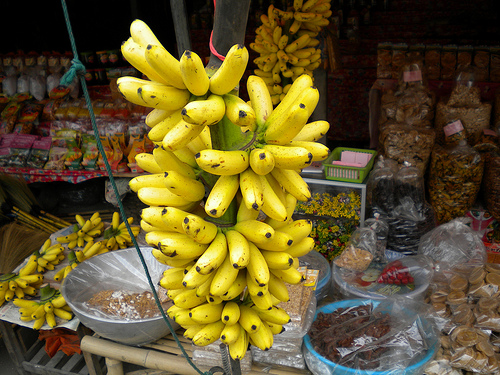Please provide a short description for this region: [0.41, 0.47, 0.47, 0.56]. This section of the image once again features the striking ripe yellow bananas, practically begging to be picked up and enjoyed right from the market stall. 